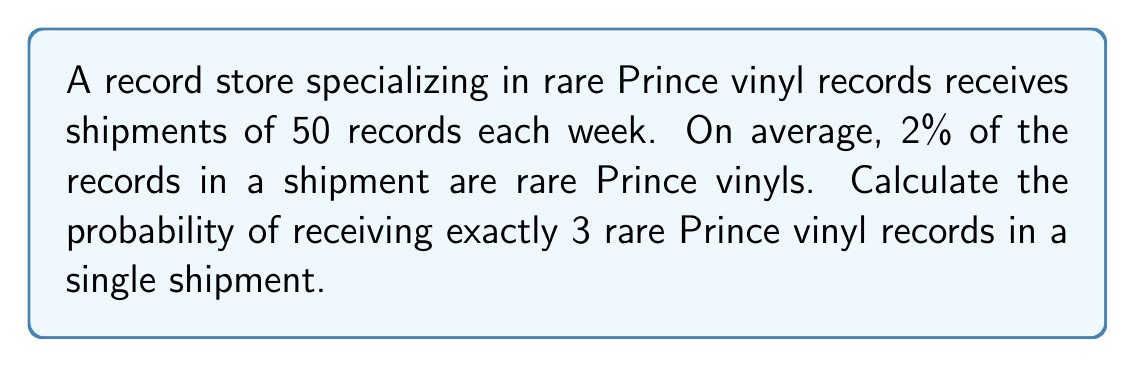Can you solve this math problem? To solve this problem, we can use the Binomial distribution, as we have a fixed number of independent trials (records in a shipment) with two possible outcomes for each trial (rare Prince vinyl or not).

Let's define our variables:
$n = 50$ (number of records in a shipment)
$p = 0.02$ (probability of a record being a rare Prince vinyl)
$k = 3$ (number of rare Prince vinyls we're interested in)

The probability mass function for the Binomial distribution is:

$$P(X = k) = \binom{n}{k} p^k (1-p)^{n-k}$$

Where $\binom{n}{k}$ is the binomial coefficient, calculated as:

$$\binom{n}{k} = \frac{n!}{k!(n-k)!}$$

Let's solve step by step:

1) Calculate the binomial coefficient:
   $$\binom{50}{3} = \frac{50!}{3!(50-3)!} = \frac{50!}{3!47!} = 19,600$$

2) Calculate $p^k$:
   $$(0.02)^3 = 0.000008$$

3) Calculate $(1-p)^{n-k}$:
   $$(1-0.02)^{50-3} = (0.98)^{47} \approx 0.3845$$

4) Put it all together in the probability mass function:
   $$P(X = 3) = 19,600 \times 0.000008 \times 0.3845 \approx 0.0603$$

Therefore, the probability of receiving exactly 3 rare Prince vinyl records in a single shipment of 50 records is approximately 0.0603 or 6.03%.
Answer: $0.0603$ or $6.03\%$ 